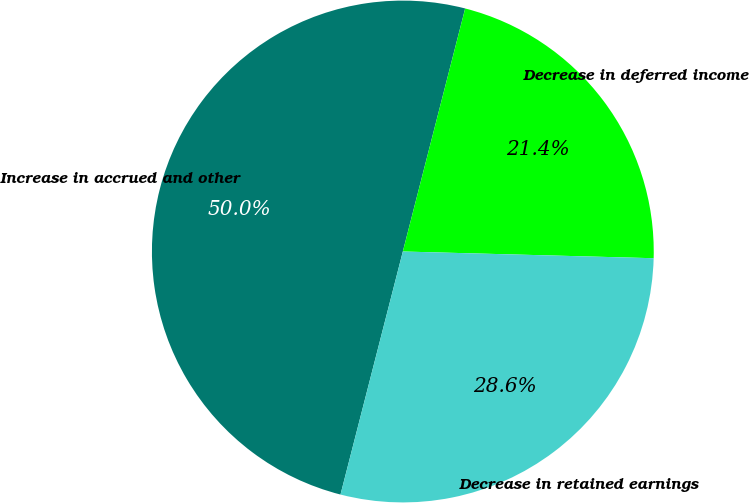Convert chart. <chart><loc_0><loc_0><loc_500><loc_500><pie_chart><fcel>Increase in accrued and other<fcel>Decrease in deferred income<fcel>Decrease in retained earnings<nl><fcel>50.0%<fcel>21.43%<fcel>28.57%<nl></chart> 